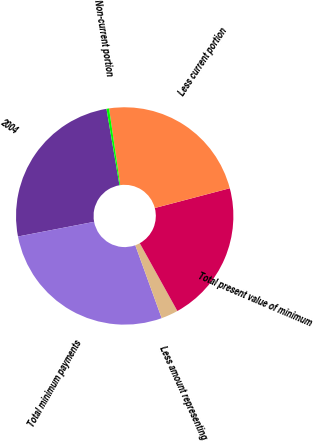Convert chart to OTSL. <chart><loc_0><loc_0><loc_500><loc_500><pie_chart><fcel>2004<fcel>Total minimum payments<fcel>Less amount representing<fcel>Total present value of minimum<fcel>Less current portion<fcel>Non-current portion<nl><fcel>25.35%<fcel>27.5%<fcel>2.53%<fcel>21.05%<fcel>23.2%<fcel>0.38%<nl></chart> 